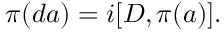<formula> <loc_0><loc_0><loc_500><loc_500>\pi ( d a ) = i [ D , \pi ( a ) ] .</formula> 